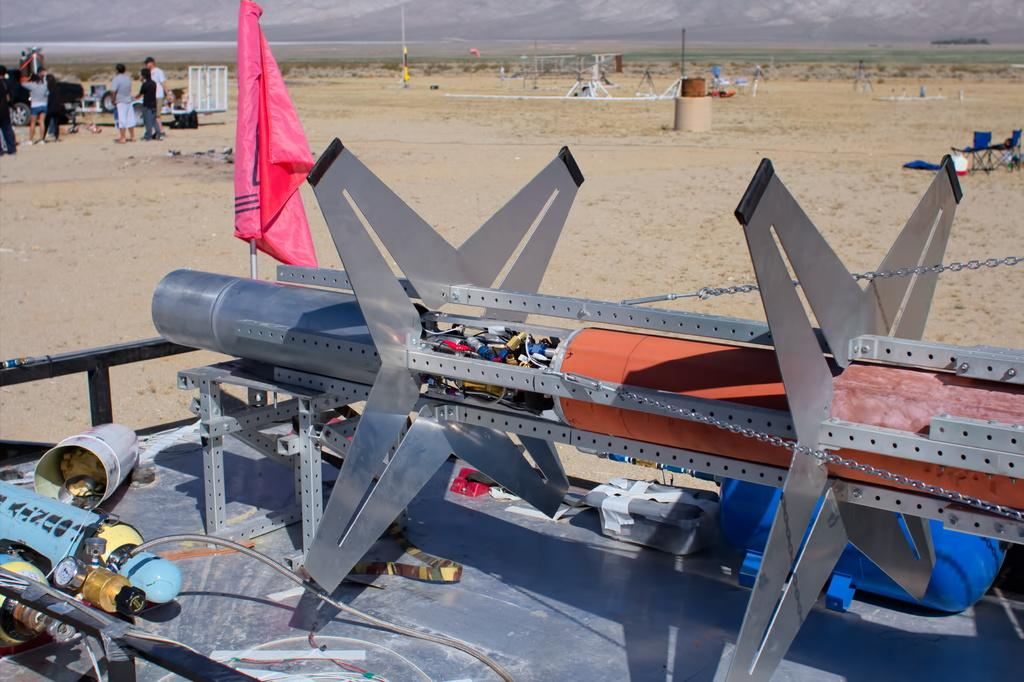What is the main object with a flag in the image? There is an object with a flag on a pole in the image. Who or what is near the object with the flag? There are people standing near the object. What else can be seen on the ground in the image? There are other objects on the ground in the image. What type of natural scenery is visible in the image? There are mountains visible in the image. What type of nerve can be seen connecting the mountains in the image? There are no nerves present in the image; it features an object with a flag, people, and other objects on the ground, with mountains visible in the background. 